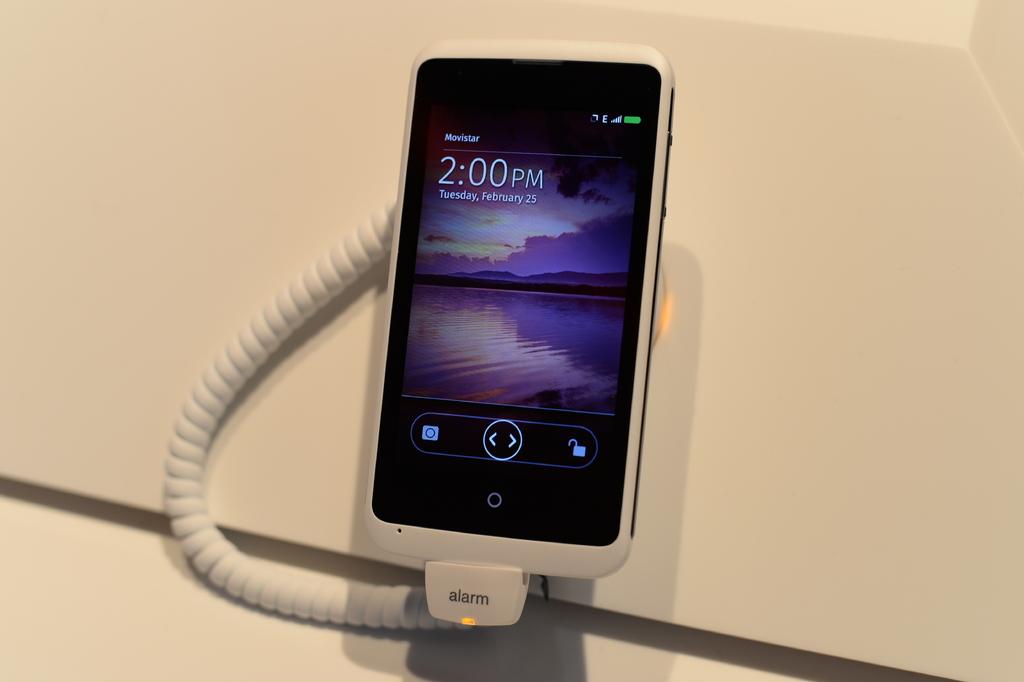What time does the phone read?
Ensure brevity in your answer.  2:00pm. 